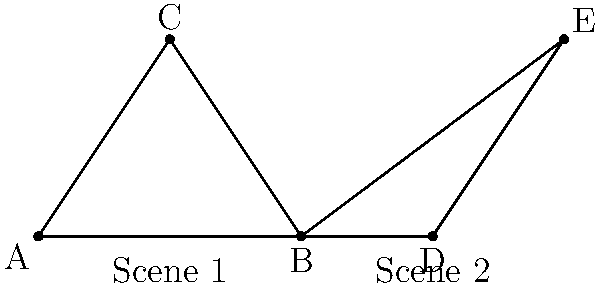In a classic film noir, two key scenes are composed using triangular compositions. The director claims these compositions are congruent to create visual continuity. Given the diagram representing these scenes, determine if triangles ABC and BDE are congruent. If so, state the congruence criterion used. To determine if triangles ABC and BDE are congruent, we need to analyze their sides and angles:

1. Side analysis:
   - AB = BD (shared side)
   - AC ≅ BE (both are diagonals of the same rectangle)
   - BC = DE (given in the diagram)

2. Angle analysis:
   - ∠BAC = ∠BDE (alternate angles, as AC and BE are parallel)
   - ∠ABC = ∠DBE (vertical angles at point B)
   - ∠BCA = ∠BED (alternate angles, as BC and DE are parallel)

3. Congruence criterion:
   Based on the analysis, we can conclude that triangles ABC and BDE are congruent using the Side-Angle-Side (SAS) criterion:
   - AB = BD (shared side)
   - ∠ABC = ∠DBE (vertical angles)
   - BC = DE (given)

4. Cinematic interpretation:
   The congruence of these triangles in the scene composition creates a visual rhyme between the two scenes, reinforcing the director's claim of visual continuity. This technique is often used in cinema to create subconscious connections between different parts of the story.
Answer: Yes, congruent; SAS criterion 